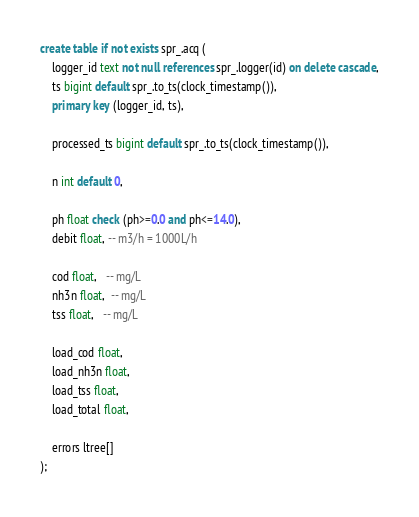Convert code to text. <code><loc_0><loc_0><loc_500><loc_500><_SQL_>create table if not exists spr_.acq (
    logger_id text not null references spr_.logger(id) on delete cascade,
    ts bigint default spr_.to_ts(clock_timestamp()),
    primary key (logger_id, ts),

    processed_ts bigint default spr_.to_ts(clock_timestamp()),

    n int default 0,

    ph float check (ph>=0.0 and ph<=14.0),
    debit float, -- m3/h = 1000L/h

    cod float,   -- mg/L
    nh3n float,  -- mg/L
    tss float,   -- mg/L

    load_cod float,
    load_nh3n float,
    load_tss float,
    load_total float,

    errors ltree[]
);

</code> 